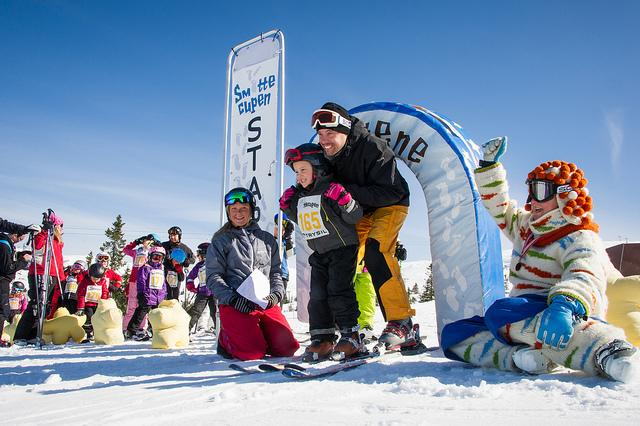Why are the children wearing numbers on their jackets? competition 